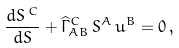Convert formula to latex. <formula><loc_0><loc_0><loc_500><loc_500>\frac { d S ^ { \, C } } { d S } + \widehat { \Gamma } _ { A B } ^ { C } \, S ^ { A } \, u ^ { B } = 0 \, ,</formula> 